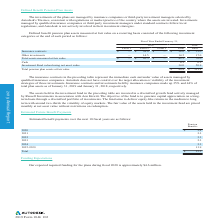According to Autodesk's financial document, What was the defined benefit pension plans as of January 31, 2019? Based on the financial document, the answer is As of January 31, 2019, the aggregate accumulated benefit obligation was $85.1 million for the defined benefit pension plans compared to $139.5 million as of January 31, 2018.. Also, How much of the company's defined benefit pension plans were funded as of January 31, 2019? Based on the financial document, the answer is 88%. Also, How much are the projected benefit obligations for 2019? Based on the financial document, the answer is $91.6 (in millions). Also, can you calculate: How much is the percentage change in the projected benefit obligations from 2018 to 2019? To answer this question, I need to perform calculations using the financial data. The calculation is: ((91.6-158.1)/158.1), which equals -42.06 (percentage). The key data points involved are: 158.1, 91.6. Also, can you calculate: What was the change in the aggregate accumulated benefit obligation from 2018 to 2019? Based on the calculation: 139.5-85.1, the result is 54.4 (in millions). The key data points involved are: 139.5, 85.1. Also, can you calculate: How much did the plan assets change from 2018 to 2019 for plans with accumulated benefit obligations in excess of plan assets? To answer this question, I need to perform calculations using the financial data. The calculation is: (70 - 112.1)/112.1 , which equals -37.56 (percentage). This is based on the information: "assets measured at fair value $ — $ 42.5 $ — 42.5 70.0 Cash 4.3 0.2 Investment Fund valued using net asset value 34.0 50.9 Total pension plan assets at..." The key data points involved are: 112.1, 70. 